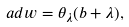Convert formula to latex. <formula><loc_0><loc_0><loc_500><loc_500>a d w = \theta _ { \lambda } ( b + \lambda ) ,</formula> 